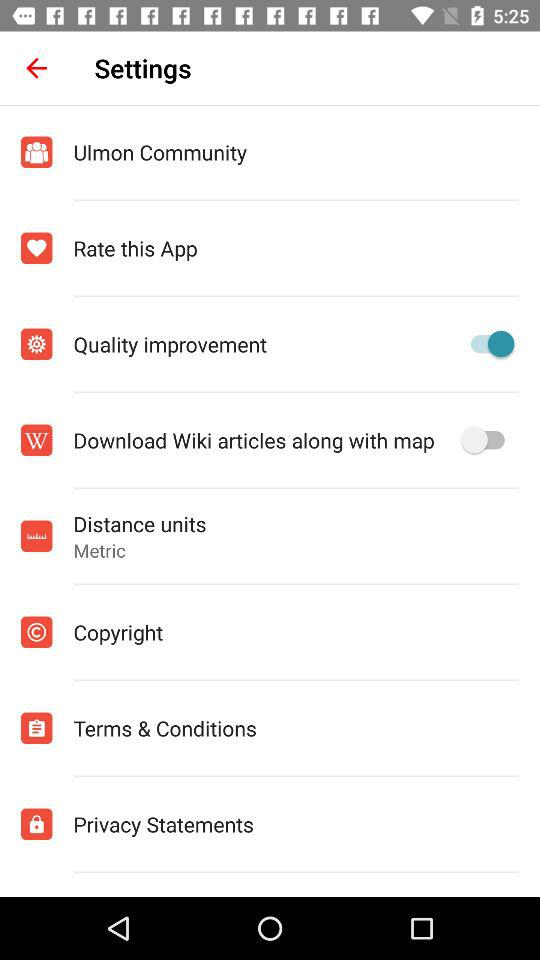What is the status of "Quality improvement"? The status of "Quality improvement" is "on". 